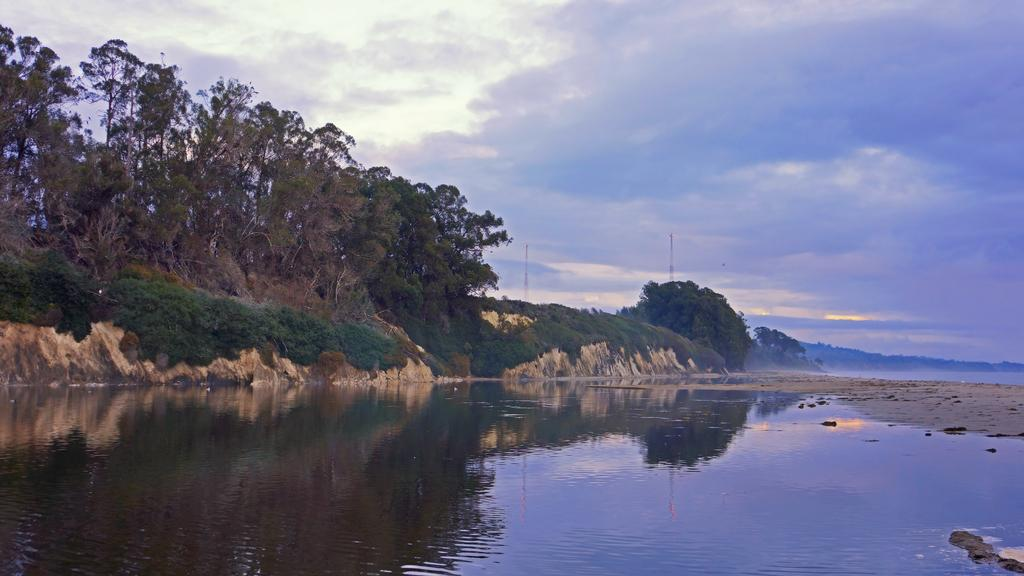What is the primary element visible in the image? There is water in the image. What type of natural vegetation can be seen in the image? There are trees in the image. What is visible in the background of the image? The sky is visible in the background of the image. What can be observed in the sky? Clouds are present in the sky. What is the level of detail in the seashore depicted in the image? There is no seashore present in the image; it features water, trees, and the sky. 